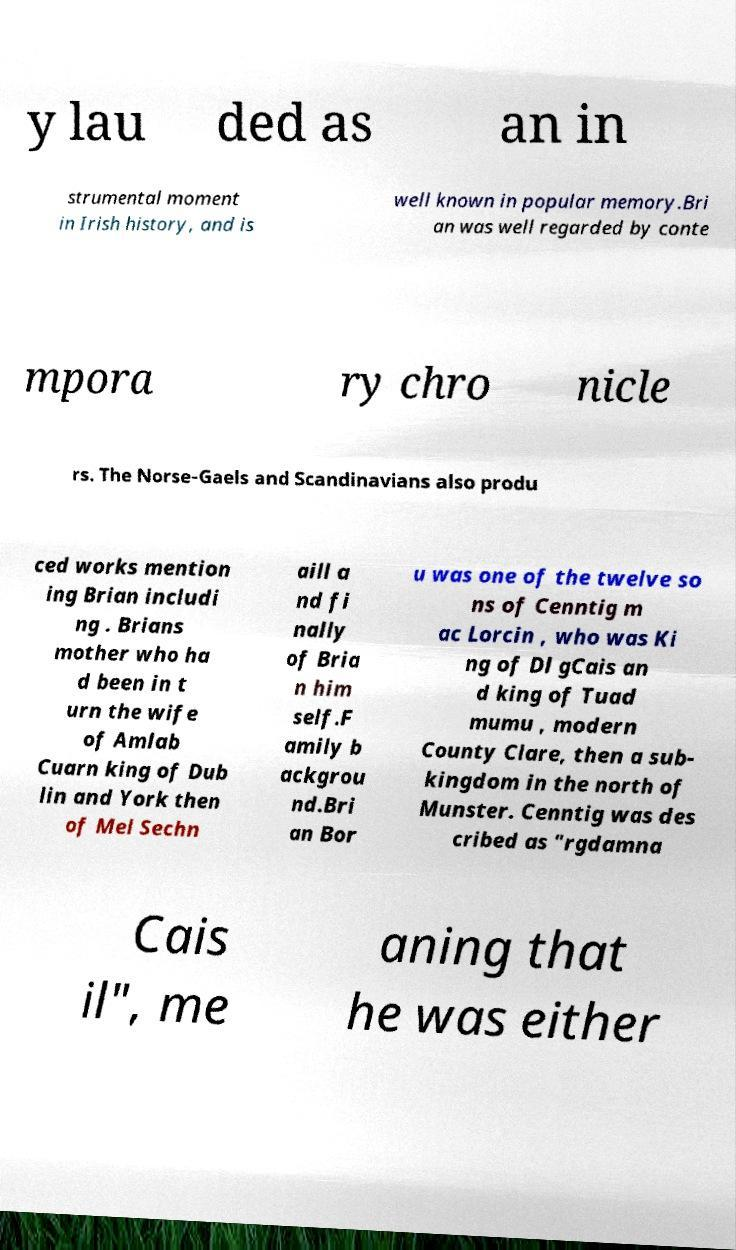Can you accurately transcribe the text from the provided image for me? y lau ded as an in strumental moment in Irish history, and is well known in popular memory.Bri an was well regarded by conte mpora ry chro nicle rs. The Norse-Gaels and Scandinavians also produ ced works mention ing Brian includi ng . Brians mother who ha d been in t urn the wife of Amlab Cuarn king of Dub lin and York then of Mel Sechn aill a nd fi nally of Bria n him self.F amily b ackgrou nd.Bri an Bor u was one of the twelve so ns of Cenntig m ac Lorcin , who was Ki ng of Dl gCais an d king of Tuad mumu , modern County Clare, then a sub- kingdom in the north of Munster. Cenntig was des cribed as "rgdamna Cais il", me aning that he was either 